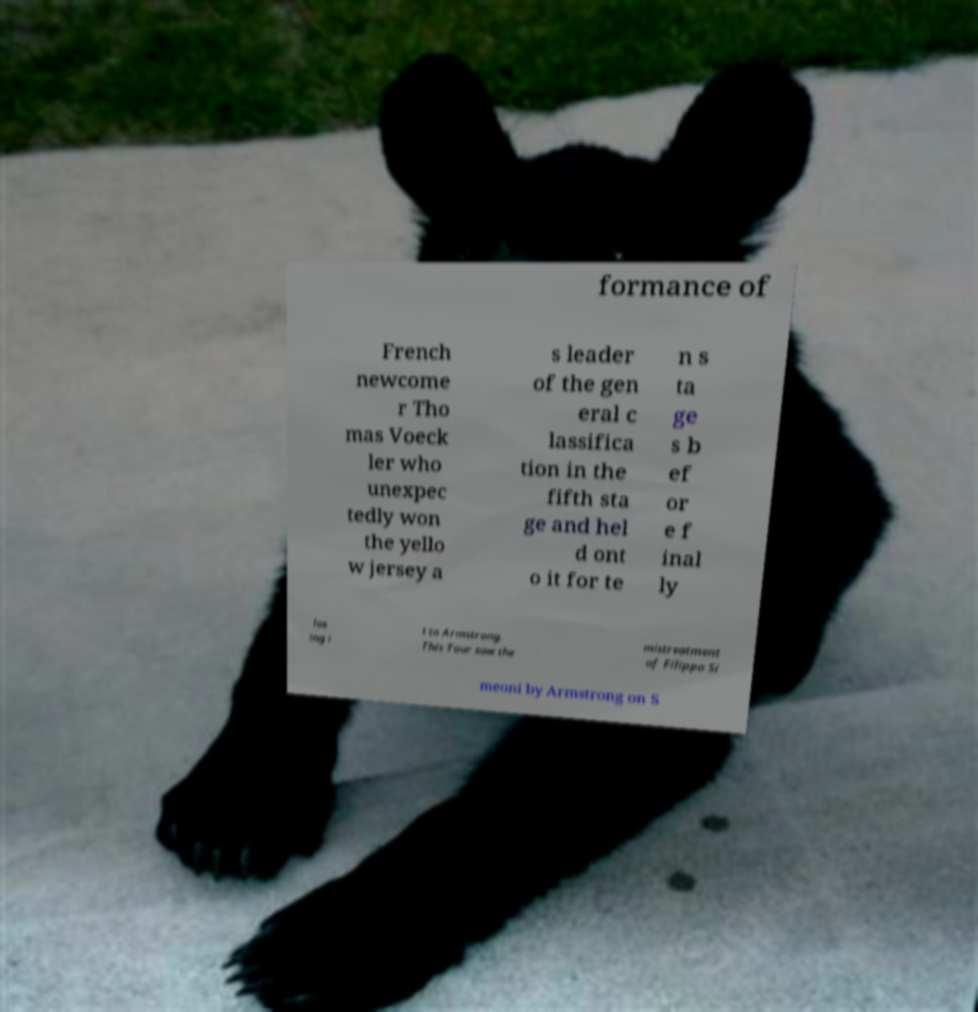I need the written content from this picture converted into text. Can you do that? formance of French newcome r Tho mas Voeck ler who unexpec tedly won the yello w jersey a s leader of the gen eral c lassifica tion in the fifth sta ge and hel d ont o it for te n s ta ge s b ef or e f inal ly los ing i t to Armstrong. This Tour saw the mistreatment of Filippo Si meoni by Armstrong on S 